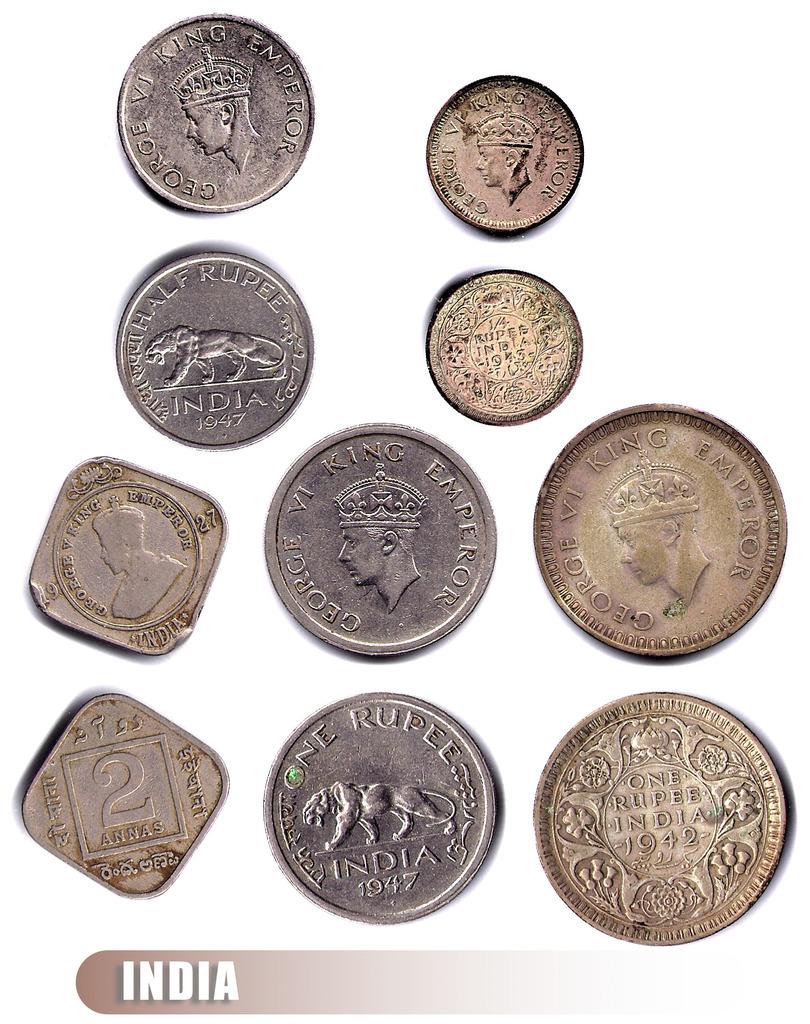Which country do these coins belong to?
Give a very brief answer. India. What year are these coins from?
Offer a terse response. 1947. 